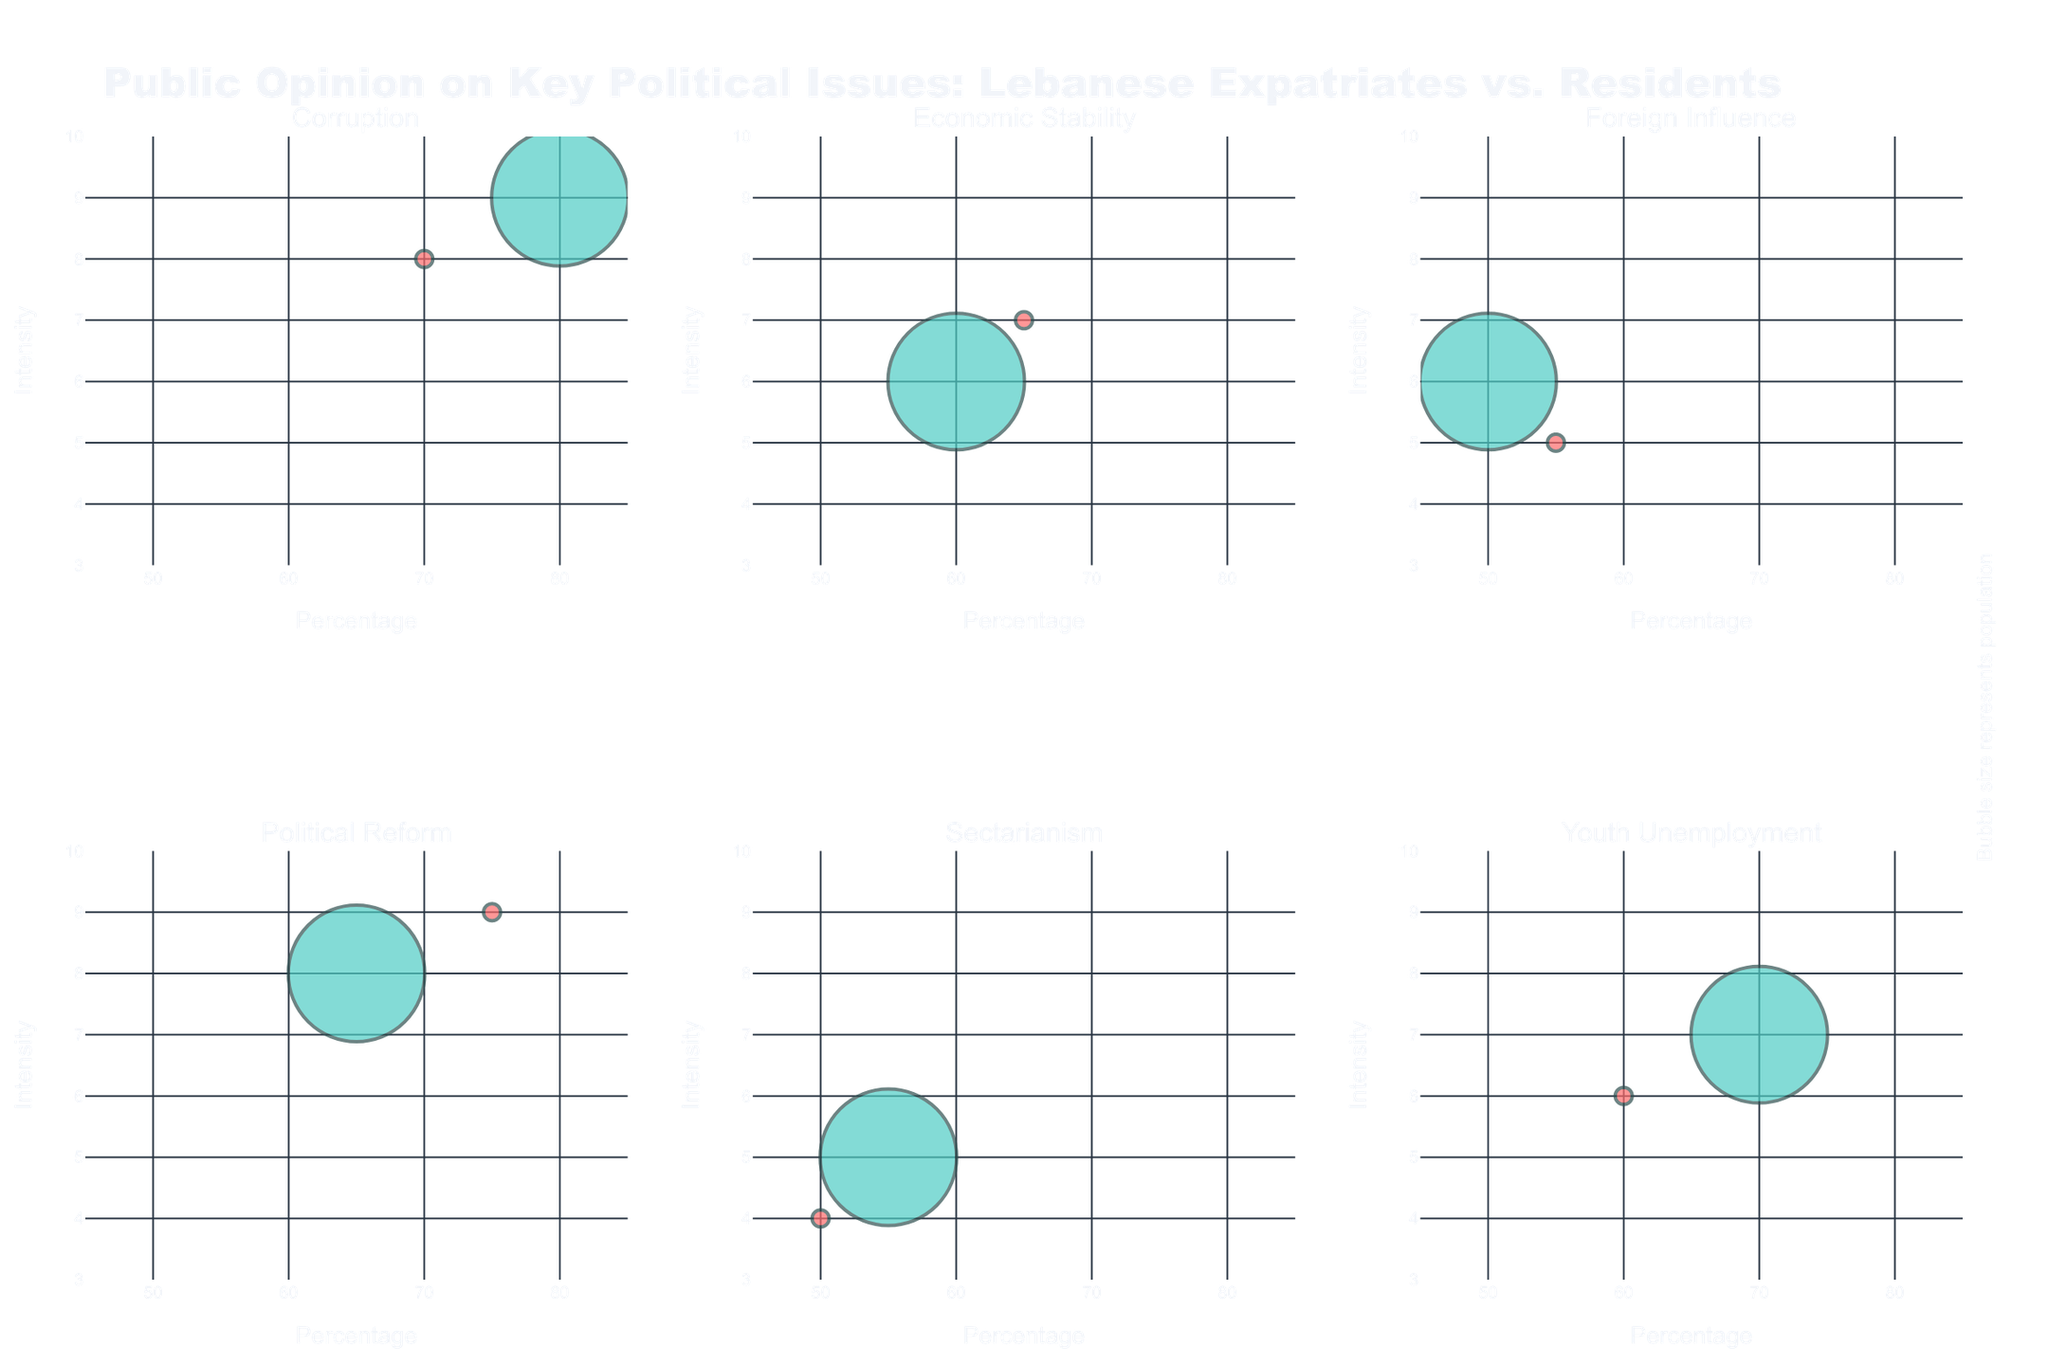What is the title of the plot? The title is usually displayed at the top of the plot. We can read it directly from this position.
Answer: Public Opinion on Key Political Issues: Lebanese Expatriates vs. Residents What are the x-axis and y-axis labels? X-axis and Y-axis labels are placed alongside the respective axes. For this plot, the x-axis is labeled "Percentage" and the y-axis is labeled "Intensity."
Answer: Percentage and Intensity How many political issues are compared in the plot? The subplot titles will indicate the number of different issues being compared. Since the titles are unique for each subplot, the number of unique issues equals the number of subplots. In this case, the number of issues is seen as subset titles.
Answer: 6 Which political issue has the highest intensity among expatriates? By examining the y-values of the bubble charts for the expatriates, we can see that the highest intensity across all issues for expatriates is for "Political Reform."
Answer: Political Reform What is the percentage difference in concern for corruption between expatriates and residents? Look at the x-values for Corruption for both expatriates and residents. The percentage for expatriates is 70%, and for residents, it is 80%. The difference can be calculated as 80 - 70 = 10%.
Answer: 10% Which group shows more concern for economic stability? Compare the x-axis value (percentage) for Economic Stability for expatriates and residents. Expatriates have a 65% concern level, while residents have a 60% concern level, so expatriates show more concern.
Answer: Expatriates How does the intensity of concern for youth unemployment compare between expatriates and residents? Compare the y-values for Youth Unemployment. Expatriates have an intensity of 6, while residents have an intensity of 7, meaning residents have a higher intensity of concern.
Answer: Residents Among the given issues, which one shows the least concern (percentage) by expatriates? Identify the x-values for expatriates across all issues and look for the smallest one. The lowest concern percentage by expatriates is for "Sectarianism" at 50%.
Answer: Sectarianism What is the relationship between the bubble size and the population in the chart? The bubble size represents population size, which can be seen in the bubbles' varying sizes on the subplot. Larger bubbles indicate a larger population, as specified by the legend annotation.
Answer: Relates to population size What is the trend of concern intensity for foreign influence between expatriates and residents? Compare y-values for Foreign Influence for both groups. Expatriates have an intensity of 5, and residents have an intensity of 6, showing a slightly higher intensity for residents.
Answer: Residents show slightly higher intensity 